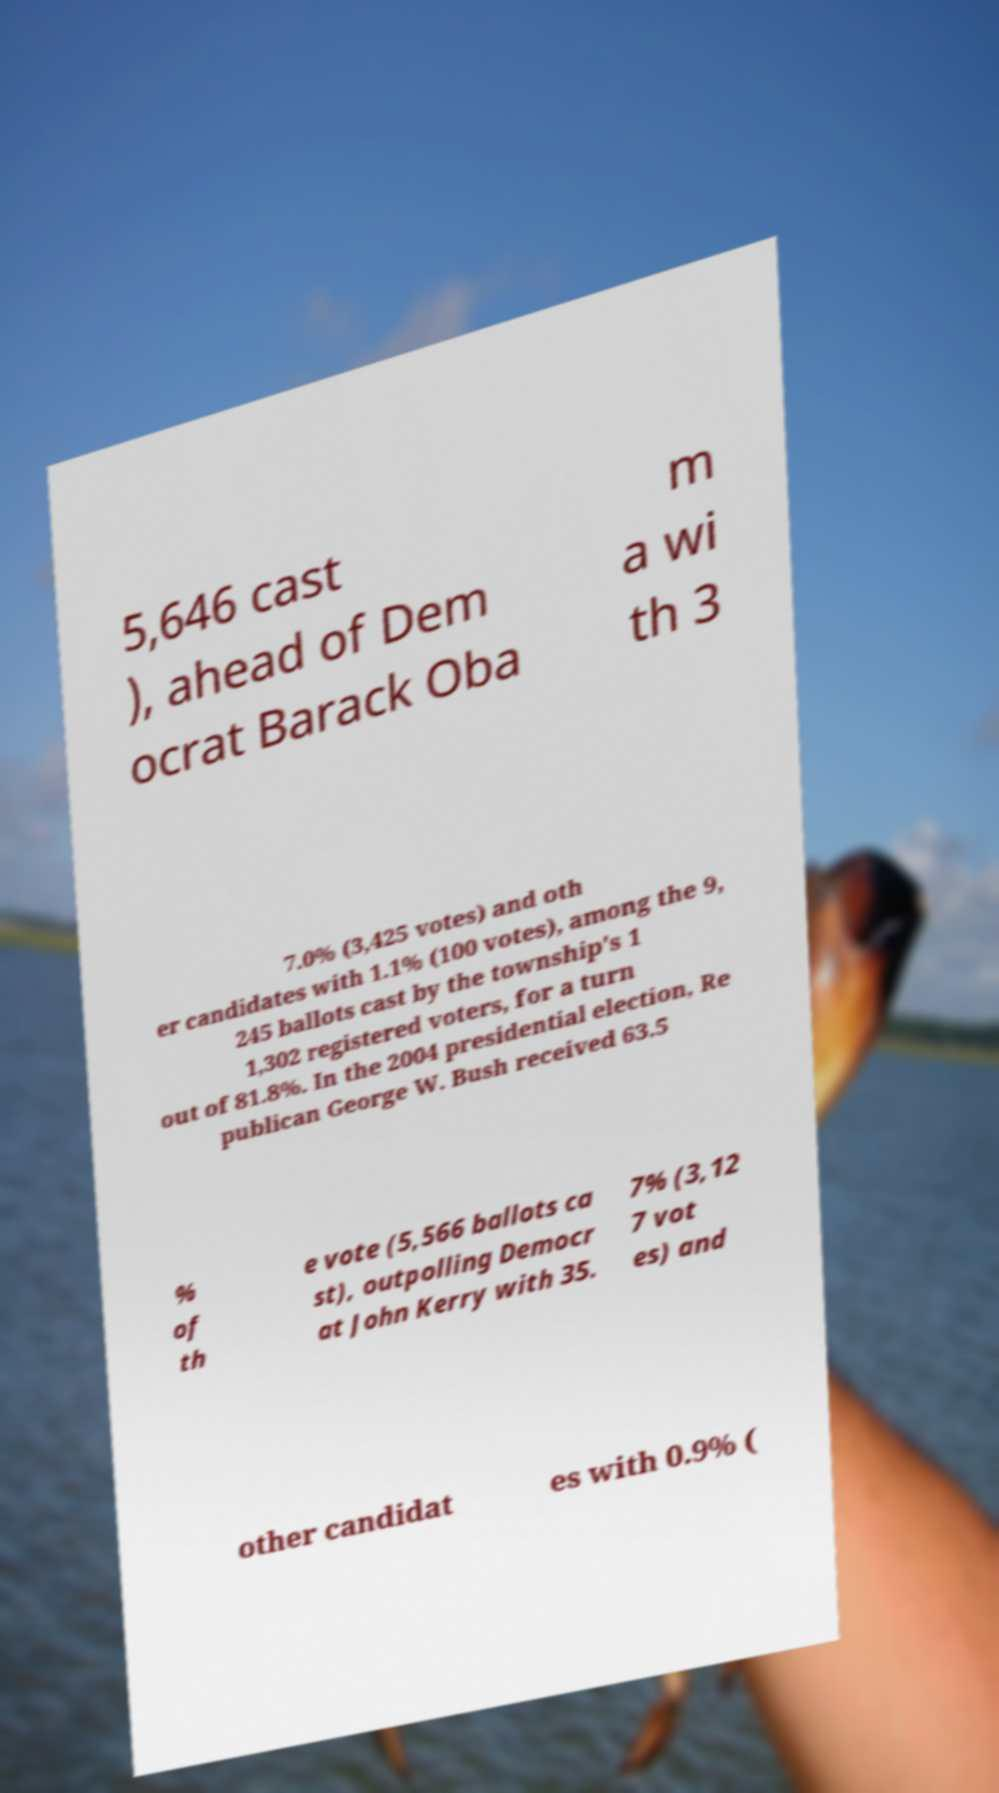Can you read and provide the text displayed in the image?This photo seems to have some interesting text. Can you extract and type it out for me? 5,646 cast ), ahead of Dem ocrat Barack Oba m a wi th 3 7.0% (3,425 votes) and oth er candidates with 1.1% (100 votes), among the 9, 245 ballots cast by the township's 1 1,302 registered voters, for a turn out of 81.8%. In the 2004 presidential election, Re publican George W. Bush received 63.5 % of th e vote (5,566 ballots ca st), outpolling Democr at John Kerry with 35. 7% (3,12 7 vot es) and other candidat es with 0.9% ( 